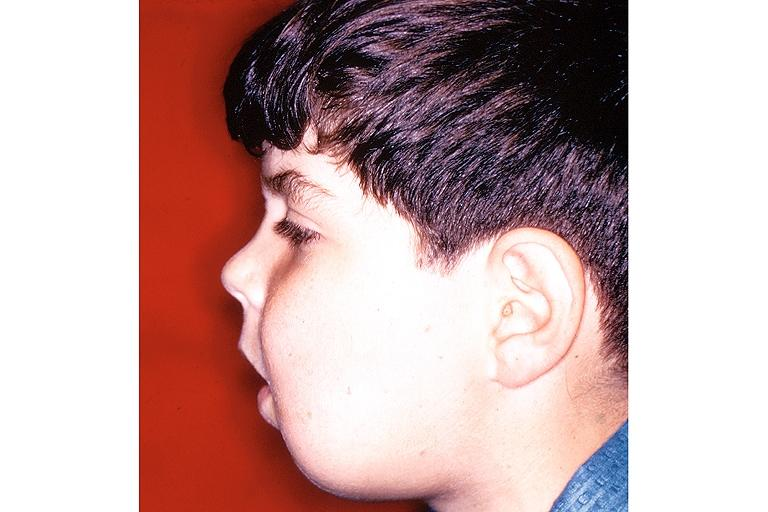s oral present?
Answer the question using a single word or phrase. Yes 